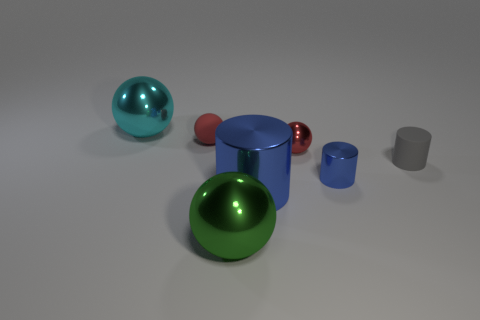Subtract all blue metallic cylinders. How many cylinders are left? 1 Subtract all cyan balls. How many balls are left? 3 Add 1 red balls. How many objects exist? 8 Subtract all cylinders. How many objects are left? 4 Subtract 0 green blocks. How many objects are left? 7 Subtract 2 balls. How many balls are left? 2 Subtract all brown cylinders. Subtract all green cubes. How many cylinders are left? 3 Subtract all purple blocks. How many purple cylinders are left? 0 Subtract all tiny brown objects. Subtract all tiny cylinders. How many objects are left? 5 Add 4 blue cylinders. How many blue cylinders are left? 6 